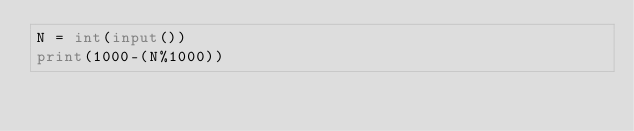Convert code to text. <code><loc_0><loc_0><loc_500><loc_500><_Python_>N = int(input())
print(1000-(N%1000))</code> 